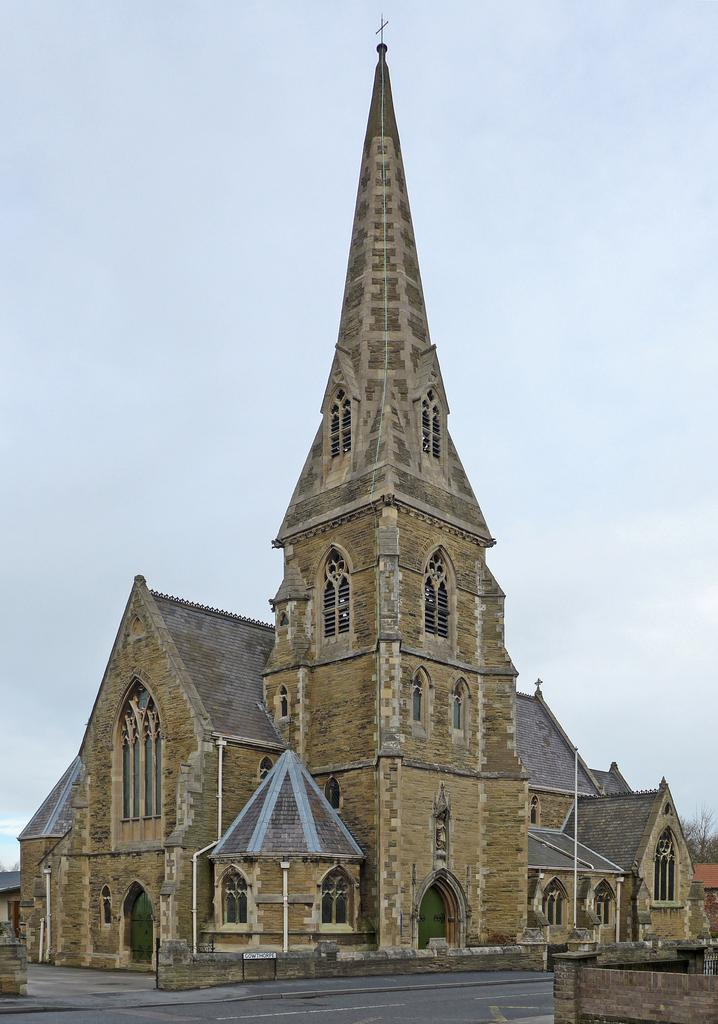What type of structure is present in the image? There is a building in the image. What other object can be seen in the image? There is a pole in the image. What can be seen in the background of the image? The sky is visible in the background of the image. What type of vegetation is present in the image? There is a tree in the image. What company is hosting the event at night in the image? There is no event or company mentioned in the image, and the time of day is not specified. Additionally, the image does not depict any support structures. 